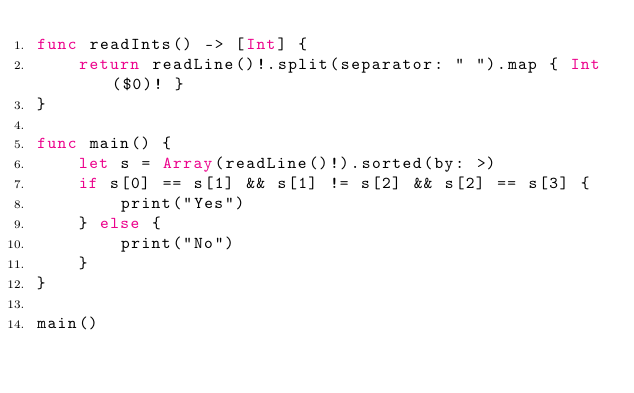Convert code to text. <code><loc_0><loc_0><loc_500><loc_500><_Swift_>func readInts() -> [Int] {
    return readLine()!.split(separator: " ").map { Int($0)! }
}

func main() {
    let s = Array(readLine()!).sorted(by: >)
    if s[0] == s[1] && s[1] != s[2] && s[2] == s[3] {
        print("Yes")
    } else {
        print("No")
    }
}

main()
</code> 